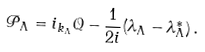Convert formula to latex. <formula><loc_0><loc_0><loc_500><loc_500>\mathcal { P } _ { \Lambda } = i _ { k _ { \Lambda } } \mathcal { Q } - { \frac { 1 } { 2 i } } ( \lambda _ { \Lambda } - \lambda ^ { * } _ { \Lambda } ) \, .</formula> 